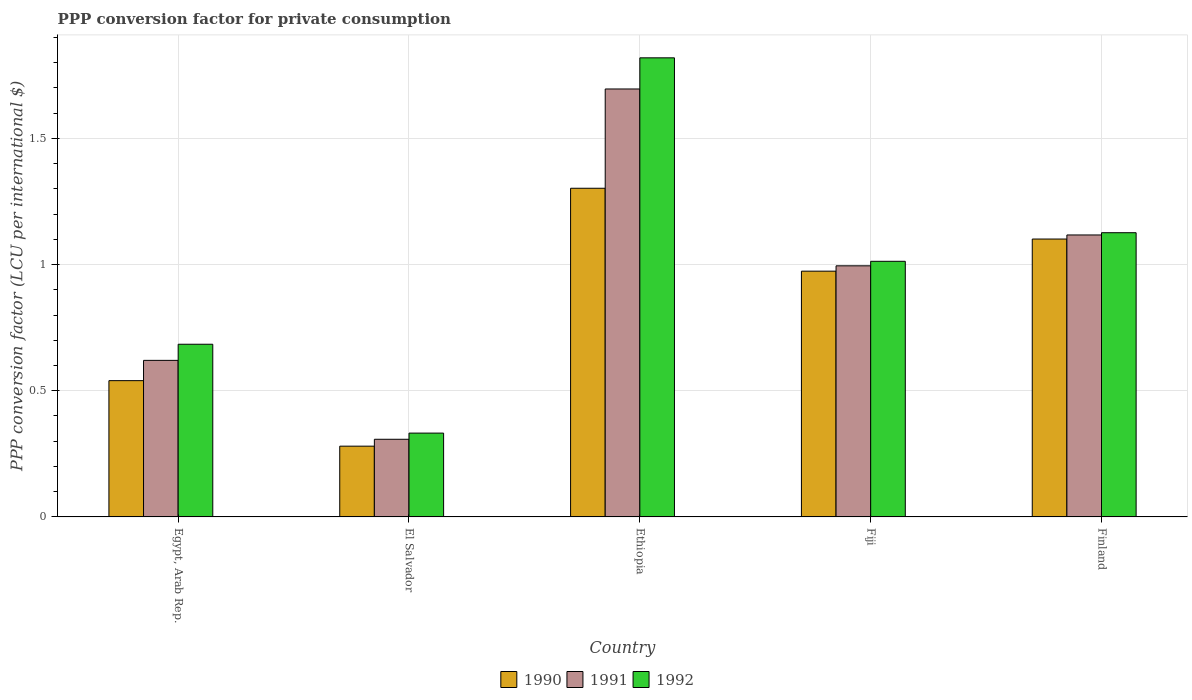How many groups of bars are there?
Keep it short and to the point. 5. How many bars are there on the 4th tick from the left?
Provide a short and direct response. 3. What is the label of the 4th group of bars from the left?
Give a very brief answer. Fiji. In how many cases, is the number of bars for a given country not equal to the number of legend labels?
Your answer should be very brief. 0. What is the PPP conversion factor for private consumption in 1992 in Egypt, Arab Rep.?
Offer a very short reply. 0.68. Across all countries, what is the maximum PPP conversion factor for private consumption in 1990?
Make the answer very short. 1.3. Across all countries, what is the minimum PPP conversion factor for private consumption in 1991?
Offer a very short reply. 0.31. In which country was the PPP conversion factor for private consumption in 1990 maximum?
Your answer should be very brief. Ethiopia. In which country was the PPP conversion factor for private consumption in 1991 minimum?
Ensure brevity in your answer.  El Salvador. What is the total PPP conversion factor for private consumption in 1990 in the graph?
Offer a terse response. 4.2. What is the difference between the PPP conversion factor for private consumption in 1991 in El Salvador and that in Finland?
Make the answer very short. -0.81. What is the difference between the PPP conversion factor for private consumption in 1992 in Fiji and the PPP conversion factor for private consumption in 1990 in Egypt, Arab Rep.?
Keep it short and to the point. 0.47. What is the average PPP conversion factor for private consumption in 1992 per country?
Ensure brevity in your answer.  0.99. What is the difference between the PPP conversion factor for private consumption of/in 1990 and PPP conversion factor for private consumption of/in 1992 in Egypt, Arab Rep.?
Your answer should be very brief. -0.14. In how many countries, is the PPP conversion factor for private consumption in 1992 greater than 1 LCU?
Offer a terse response. 3. What is the ratio of the PPP conversion factor for private consumption in 1992 in Ethiopia to that in Finland?
Provide a short and direct response. 1.62. What is the difference between the highest and the second highest PPP conversion factor for private consumption in 1992?
Provide a succinct answer. 0.69. What is the difference between the highest and the lowest PPP conversion factor for private consumption in 1991?
Offer a terse response. 1.39. In how many countries, is the PPP conversion factor for private consumption in 1990 greater than the average PPP conversion factor for private consumption in 1990 taken over all countries?
Your answer should be very brief. 3. What does the 2nd bar from the left in El Salvador represents?
Offer a very short reply. 1991. Are all the bars in the graph horizontal?
Provide a succinct answer. No. Does the graph contain grids?
Ensure brevity in your answer.  Yes. Where does the legend appear in the graph?
Your answer should be compact. Bottom center. What is the title of the graph?
Offer a terse response. PPP conversion factor for private consumption. What is the label or title of the X-axis?
Make the answer very short. Country. What is the label or title of the Y-axis?
Your response must be concise. PPP conversion factor (LCU per international $). What is the PPP conversion factor (LCU per international $) of 1990 in Egypt, Arab Rep.?
Keep it short and to the point. 0.54. What is the PPP conversion factor (LCU per international $) of 1991 in Egypt, Arab Rep.?
Your answer should be compact. 0.62. What is the PPP conversion factor (LCU per international $) of 1992 in Egypt, Arab Rep.?
Provide a succinct answer. 0.68. What is the PPP conversion factor (LCU per international $) of 1990 in El Salvador?
Offer a very short reply. 0.28. What is the PPP conversion factor (LCU per international $) of 1991 in El Salvador?
Your answer should be compact. 0.31. What is the PPP conversion factor (LCU per international $) of 1992 in El Salvador?
Keep it short and to the point. 0.33. What is the PPP conversion factor (LCU per international $) of 1990 in Ethiopia?
Ensure brevity in your answer.  1.3. What is the PPP conversion factor (LCU per international $) in 1991 in Ethiopia?
Your answer should be very brief. 1.7. What is the PPP conversion factor (LCU per international $) of 1992 in Ethiopia?
Your answer should be very brief. 1.82. What is the PPP conversion factor (LCU per international $) of 1990 in Fiji?
Your answer should be compact. 0.97. What is the PPP conversion factor (LCU per international $) of 1991 in Fiji?
Provide a short and direct response. 1. What is the PPP conversion factor (LCU per international $) of 1992 in Fiji?
Make the answer very short. 1.01. What is the PPP conversion factor (LCU per international $) in 1990 in Finland?
Make the answer very short. 1.1. What is the PPP conversion factor (LCU per international $) of 1991 in Finland?
Your answer should be compact. 1.12. What is the PPP conversion factor (LCU per international $) of 1992 in Finland?
Offer a very short reply. 1.13. Across all countries, what is the maximum PPP conversion factor (LCU per international $) of 1990?
Keep it short and to the point. 1.3. Across all countries, what is the maximum PPP conversion factor (LCU per international $) of 1991?
Give a very brief answer. 1.7. Across all countries, what is the maximum PPP conversion factor (LCU per international $) in 1992?
Offer a terse response. 1.82. Across all countries, what is the minimum PPP conversion factor (LCU per international $) in 1990?
Your answer should be very brief. 0.28. Across all countries, what is the minimum PPP conversion factor (LCU per international $) in 1991?
Your answer should be very brief. 0.31. Across all countries, what is the minimum PPP conversion factor (LCU per international $) of 1992?
Keep it short and to the point. 0.33. What is the total PPP conversion factor (LCU per international $) of 1990 in the graph?
Ensure brevity in your answer.  4.2. What is the total PPP conversion factor (LCU per international $) in 1991 in the graph?
Ensure brevity in your answer.  4.74. What is the total PPP conversion factor (LCU per international $) in 1992 in the graph?
Offer a very short reply. 4.97. What is the difference between the PPP conversion factor (LCU per international $) in 1990 in Egypt, Arab Rep. and that in El Salvador?
Your answer should be compact. 0.26. What is the difference between the PPP conversion factor (LCU per international $) in 1991 in Egypt, Arab Rep. and that in El Salvador?
Your response must be concise. 0.31. What is the difference between the PPP conversion factor (LCU per international $) of 1992 in Egypt, Arab Rep. and that in El Salvador?
Offer a very short reply. 0.35. What is the difference between the PPP conversion factor (LCU per international $) of 1990 in Egypt, Arab Rep. and that in Ethiopia?
Give a very brief answer. -0.76. What is the difference between the PPP conversion factor (LCU per international $) of 1991 in Egypt, Arab Rep. and that in Ethiopia?
Offer a very short reply. -1.08. What is the difference between the PPP conversion factor (LCU per international $) in 1992 in Egypt, Arab Rep. and that in Ethiopia?
Your answer should be very brief. -1.14. What is the difference between the PPP conversion factor (LCU per international $) of 1990 in Egypt, Arab Rep. and that in Fiji?
Your answer should be very brief. -0.43. What is the difference between the PPP conversion factor (LCU per international $) of 1991 in Egypt, Arab Rep. and that in Fiji?
Make the answer very short. -0.37. What is the difference between the PPP conversion factor (LCU per international $) of 1992 in Egypt, Arab Rep. and that in Fiji?
Provide a short and direct response. -0.33. What is the difference between the PPP conversion factor (LCU per international $) of 1990 in Egypt, Arab Rep. and that in Finland?
Provide a short and direct response. -0.56. What is the difference between the PPP conversion factor (LCU per international $) in 1991 in Egypt, Arab Rep. and that in Finland?
Your response must be concise. -0.5. What is the difference between the PPP conversion factor (LCU per international $) in 1992 in Egypt, Arab Rep. and that in Finland?
Provide a short and direct response. -0.44. What is the difference between the PPP conversion factor (LCU per international $) of 1990 in El Salvador and that in Ethiopia?
Offer a very short reply. -1.02. What is the difference between the PPP conversion factor (LCU per international $) in 1991 in El Salvador and that in Ethiopia?
Make the answer very short. -1.39. What is the difference between the PPP conversion factor (LCU per international $) of 1992 in El Salvador and that in Ethiopia?
Your answer should be compact. -1.49. What is the difference between the PPP conversion factor (LCU per international $) of 1990 in El Salvador and that in Fiji?
Your answer should be very brief. -0.69. What is the difference between the PPP conversion factor (LCU per international $) in 1991 in El Salvador and that in Fiji?
Provide a succinct answer. -0.69. What is the difference between the PPP conversion factor (LCU per international $) in 1992 in El Salvador and that in Fiji?
Provide a short and direct response. -0.68. What is the difference between the PPP conversion factor (LCU per international $) of 1990 in El Salvador and that in Finland?
Ensure brevity in your answer.  -0.82. What is the difference between the PPP conversion factor (LCU per international $) in 1991 in El Salvador and that in Finland?
Provide a succinct answer. -0.81. What is the difference between the PPP conversion factor (LCU per international $) in 1992 in El Salvador and that in Finland?
Provide a succinct answer. -0.79. What is the difference between the PPP conversion factor (LCU per international $) in 1990 in Ethiopia and that in Fiji?
Offer a very short reply. 0.33. What is the difference between the PPP conversion factor (LCU per international $) in 1991 in Ethiopia and that in Fiji?
Provide a short and direct response. 0.7. What is the difference between the PPP conversion factor (LCU per international $) in 1992 in Ethiopia and that in Fiji?
Your answer should be very brief. 0.81. What is the difference between the PPP conversion factor (LCU per international $) in 1990 in Ethiopia and that in Finland?
Provide a succinct answer. 0.2. What is the difference between the PPP conversion factor (LCU per international $) in 1991 in Ethiopia and that in Finland?
Keep it short and to the point. 0.58. What is the difference between the PPP conversion factor (LCU per international $) in 1992 in Ethiopia and that in Finland?
Give a very brief answer. 0.69. What is the difference between the PPP conversion factor (LCU per international $) in 1990 in Fiji and that in Finland?
Your response must be concise. -0.13. What is the difference between the PPP conversion factor (LCU per international $) in 1991 in Fiji and that in Finland?
Offer a very short reply. -0.12. What is the difference between the PPP conversion factor (LCU per international $) of 1992 in Fiji and that in Finland?
Your response must be concise. -0.11. What is the difference between the PPP conversion factor (LCU per international $) in 1990 in Egypt, Arab Rep. and the PPP conversion factor (LCU per international $) in 1991 in El Salvador?
Provide a succinct answer. 0.23. What is the difference between the PPP conversion factor (LCU per international $) in 1990 in Egypt, Arab Rep. and the PPP conversion factor (LCU per international $) in 1992 in El Salvador?
Give a very brief answer. 0.21. What is the difference between the PPP conversion factor (LCU per international $) of 1991 in Egypt, Arab Rep. and the PPP conversion factor (LCU per international $) of 1992 in El Salvador?
Ensure brevity in your answer.  0.29. What is the difference between the PPP conversion factor (LCU per international $) of 1990 in Egypt, Arab Rep. and the PPP conversion factor (LCU per international $) of 1991 in Ethiopia?
Keep it short and to the point. -1.16. What is the difference between the PPP conversion factor (LCU per international $) of 1990 in Egypt, Arab Rep. and the PPP conversion factor (LCU per international $) of 1992 in Ethiopia?
Keep it short and to the point. -1.28. What is the difference between the PPP conversion factor (LCU per international $) in 1991 in Egypt, Arab Rep. and the PPP conversion factor (LCU per international $) in 1992 in Ethiopia?
Offer a terse response. -1.2. What is the difference between the PPP conversion factor (LCU per international $) in 1990 in Egypt, Arab Rep. and the PPP conversion factor (LCU per international $) in 1991 in Fiji?
Provide a short and direct response. -0.46. What is the difference between the PPP conversion factor (LCU per international $) of 1990 in Egypt, Arab Rep. and the PPP conversion factor (LCU per international $) of 1992 in Fiji?
Offer a very short reply. -0.47. What is the difference between the PPP conversion factor (LCU per international $) of 1991 in Egypt, Arab Rep. and the PPP conversion factor (LCU per international $) of 1992 in Fiji?
Your answer should be compact. -0.39. What is the difference between the PPP conversion factor (LCU per international $) in 1990 in Egypt, Arab Rep. and the PPP conversion factor (LCU per international $) in 1991 in Finland?
Offer a very short reply. -0.58. What is the difference between the PPP conversion factor (LCU per international $) in 1990 in Egypt, Arab Rep. and the PPP conversion factor (LCU per international $) in 1992 in Finland?
Provide a succinct answer. -0.59. What is the difference between the PPP conversion factor (LCU per international $) in 1991 in Egypt, Arab Rep. and the PPP conversion factor (LCU per international $) in 1992 in Finland?
Give a very brief answer. -0.51. What is the difference between the PPP conversion factor (LCU per international $) in 1990 in El Salvador and the PPP conversion factor (LCU per international $) in 1991 in Ethiopia?
Your answer should be very brief. -1.42. What is the difference between the PPP conversion factor (LCU per international $) of 1990 in El Salvador and the PPP conversion factor (LCU per international $) of 1992 in Ethiopia?
Your answer should be very brief. -1.54. What is the difference between the PPP conversion factor (LCU per international $) of 1991 in El Salvador and the PPP conversion factor (LCU per international $) of 1992 in Ethiopia?
Provide a short and direct response. -1.51. What is the difference between the PPP conversion factor (LCU per international $) of 1990 in El Salvador and the PPP conversion factor (LCU per international $) of 1991 in Fiji?
Provide a succinct answer. -0.71. What is the difference between the PPP conversion factor (LCU per international $) in 1990 in El Salvador and the PPP conversion factor (LCU per international $) in 1992 in Fiji?
Provide a succinct answer. -0.73. What is the difference between the PPP conversion factor (LCU per international $) of 1991 in El Salvador and the PPP conversion factor (LCU per international $) of 1992 in Fiji?
Ensure brevity in your answer.  -0.71. What is the difference between the PPP conversion factor (LCU per international $) of 1990 in El Salvador and the PPP conversion factor (LCU per international $) of 1991 in Finland?
Offer a very short reply. -0.84. What is the difference between the PPP conversion factor (LCU per international $) of 1990 in El Salvador and the PPP conversion factor (LCU per international $) of 1992 in Finland?
Offer a very short reply. -0.85. What is the difference between the PPP conversion factor (LCU per international $) in 1991 in El Salvador and the PPP conversion factor (LCU per international $) in 1992 in Finland?
Offer a terse response. -0.82. What is the difference between the PPP conversion factor (LCU per international $) of 1990 in Ethiopia and the PPP conversion factor (LCU per international $) of 1991 in Fiji?
Provide a short and direct response. 0.31. What is the difference between the PPP conversion factor (LCU per international $) of 1990 in Ethiopia and the PPP conversion factor (LCU per international $) of 1992 in Fiji?
Make the answer very short. 0.29. What is the difference between the PPP conversion factor (LCU per international $) of 1991 in Ethiopia and the PPP conversion factor (LCU per international $) of 1992 in Fiji?
Your answer should be very brief. 0.68. What is the difference between the PPP conversion factor (LCU per international $) in 1990 in Ethiopia and the PPP conversion factor (LCU per international $) in 1991 in Finland?
Offer a very short reply. 0.19. What is the difference between the PPP conversion factor (LCU per international $) in 1990 in Ethiopia and the PPP conversion factor (LCU per international $) in 1992 in Finland?
Your answer should be compact. 0.18. What is the difference between the PPP conversion factor (LCU per international $) in 1991 in Ethiopia and the PPP conversion factor (LCU per international $) in 1992 in Finland?
Ensure brevity in your answer.  0.57. What is the difference between the PPP conversion factor (LCU per international $) in 1990 in Fiji and the PPP conversion factor (LCU per international $) in 1991 in Finland?
Offer a very short reply. -0.14. What is the difference between the PPP conversion factor (LCU per international $) in 1990 in Fiji and the PPP conversion factor (LCU per international $) in 1992 in Finland?
Make the answer very short. -0.15. What is the difference between the PPP conversion factor (LCU per international $) of 1991 in Fiji and the PPP conversion factor (LCU per international $) of 1992 in Finland?
Give a very brief answer. -0.13. What is the average PPP conversion factor (LCU per international $) of 1990 per country?
Your response must be concise. 0.84. What is the average PPP conversion factor (LCU per international $) of 1991 per country?
Offer a very short reply. 0.95. What is the difference between the PPP conversion factor (LCU per international $) in 1990 and PPP conversion factor (LCU per international $) in 1991 in Egypt, Arab Rep.?
Your answer should be very brief. -0.08. What is the difference between the PPP conversion factor (LCU per international $) of 1990 and PPP conversion factor (LCU per international $) of 1992 in Egypt, Arab Rep.?
Provide a short and direct response. -0.14. What is the difference between the PPP conversion factor (LCU per international $) in 1991 and PPP conversion factor (LCU per international $) in 1992 in Egypt, Arab Rep.?
Offer a terse response. -0.06. What is the difference between the PPP conversion factor (LCU per international $) of 1990 and PPP conversion factor (LCU per international $) of 1991 in El Salvador?
Make the answer very short. -0.03. What is the difference between the PPP conversion factor (LCU per international $) of 1990 and PPP conversion factor (LCU per international $) of 1992 in El Salvador?
Provide a succinct answer. -0.05. What is the difference between the PPP conversion factor (LCU per international $) in 1991 and PPP conversion factor (LCU per international $) in 1992 in El Salvador?
Offer a terse response. -0.02. What is the difference between the PPP conversion factor (LCU per international $) of 1990 and PPP conversion factor (LCU per international $) of 1991 in Ethiopia?
Ensure brevity in your answer.  -0.39. What is the difference between the PPP conversion factor (LCU per international $) of 1990 and PPP conversion factor (LCU per international $) of 1992 in Ethiopia?
Your answer should be very brief. -0.52. What is the difference between the PPP conversion factor (LCU per international $) in 1991 and PPP conversion factor (LCU per international $) in 1992 in Ethiopia?
Make the answer very short. -0.12. What is the difference between the PPP conversion factor (LCU per international $) in 1990 and PPP conversion factor (LCU per international $) in 1991 in Fiji?
Ensure brevity in your answer.  -0.02. What is the difference between the PPP conversion factor (LCU per international $) of 1990 and PPP conversion factor (LCU per international $) of 1992 in Fiji?
Offer a terse response. -0.04. What is the difference between the PPP conversion factor (LCU per international $) in 1991 and PPP conversion factor (LCU per international $) in 1992 in Fiji?
Offer a terse response. -0.02. What is the difference between the PPP conversion factor (LCU per international $) in 1990 and PPP conversion factor (LCU per international $) in 1991 in Finland?
Offer a very short reply. -0.02. What is the difference between the PPP conversion factor (LCU per international $) of 1990 and PPP conversion factor (LCU per international $) of 1992 in Finland?
Your answer should be compact. -0.03. What is the difference between the PPP conversion factor (LCU per international $) in 1991 and PPP conversion factor (LCU per international $) in 1992 in Finland?
Your answer should be compact. -0.01. What is the ratio of the PPP conversion factor (LCU per international $) of 1990 in Egypt, Arab Rep. to that in El Salvador?
Offer a terse response. 1.93. What is the ratio of the PPP conversion factor (LCU per international $) in 1991 in Egypt, Arab Rep. to that in El Salvador?
Keep it short and to the point. 2.02. What is the ratio of the PPP conversion factor (LCU per international $) of 1992 in Egypt, Arab Rep. to that in El Salvador?
Your response must be concise. 2.06. What is the ratio of the PPP conversion factor (LCU per international $) in 1990 in Egypt, Arab Rep. to that in Ethiopia?
Provide a succinct answer. 0.41. What is the ratio of the PPP conversion factor (LCU per international $) of 1991 in Egypt, Arab Rep. to that in Ethiopia?
Offer a very short reply. 0.37. What is the ratio of the PPP conversion factor (LCU per international $) in 1992 in Egypt, Arab Rep. to that in Ethiopia?
Offer a terse response. 0.38. What is the ratio of the PPP conversion factor (LCU per international $) in 1990 in Egypt, Arab Rep. to that in Fiji?
Provide a short and direct response. 0.55. What is the ratio of the PPP conversion factor (LCU per international $) of 1991 in Egypt, Arab Rep. to that in Fiji?
Your answer should be very brief. 0.62. What is the ratio of the PPP conversion factor (LCU per international $) of 1992 in Egypt, Arab Rep. to that in Fiji?
Offer a very short reply. 0.68. What is the ratio of the PPP conversion factor (LCU per international $) of 1990 in Egypt, Arab Rep. to that in Finland?
Your response must be concise. 0.49. What is the ratio of the PPP conversion factor (LCU per international $) in 1991 in Egypt, Arab Rep. to that in Finland?
Give a very brief answer. 0.56. What is the ratio of the PPP conversion factor (LCU per international $) of 1992 in Egypt, Arab Rep. to that in Finland?
Give a very brief answer. 0.61. What is the ratio of the PPP conversion factor (LCU per international $) in 1990 in El Salvador to that in Ethiopia?
Keep it short and to the point. 0.22. What is the ratio of the PPP conversion factor (LCU per international $) in 1991 in El Salvador to that in Ethiopia?
Your response must be concise. 0.18. What is the ratio of the PPP conversion factor (LCU per international $) in 1992 in El Salvador to that in Ethiopia?
Offer a terse response. 0.18. What is the ratio of the PPP conversion factor (LCU per international $) in 1990 in El Salvador to that in Fiji?
Make the answer very short. 0.29. What is the ratio of the PPP conversion factor (LCU per international $) in 1991 in El Salvador to that in Fiji?
Offer a terse response. 0.31. What is the ratio of the PPP conversion factor (LCU per international $) of 1992 in El Salvador to that in Fiji?
Provide a short and direct response. 0.33. What is the ratio of the PPP conversion factor (LCU per international $) in 1990 in El Salvador to that in Finland?
Your response must be concise. 0.25. What is the ratio of the PPP conversion factor (LCU per international $) in 1991 in El Salvador to that in Finland?
Provide a short and direct response. 0.28. What is the ratio of the PPP conversion factor (LCU per international $) of 1992 in El Salvador to that in Finland?
Offer a very short reply. 0.29. What is the ratio of the PPP conversion factor (LCU per international $) in 1990 in Ethiopia to that in Fiji?
Your answer should be very brief. 1.34. What is the ratio of the PPP conversion factor (LCU per international $) in 1991 in Ethiopia to that in Fiji?
Offer a very short reply. 1.7. What is the ratio of the PPP conversion factor (LCU per international $) of 1992 in Ethiopia to that in Fiji?
Provide a short and direct response. 1.8. What is the ratio of the PPP conversion factor (LCU per international $) of 1990 in Ethiopia to that in Finland?
Offer a terse response. 1.18. What is the ratio of the PPP conversion factor (LCU per international $) of 1991 in Ethiopia to that in Finland?
Your answer should be very brief. 1.52. What is the ratio of the PPP conversion factor (LCU per international $) of 1992 in Ethiopia to that in Finland?
Keep it short and to the point. 1.62. What is the ratio of the PPP conversion factor (LCU per international $) of 1990 in Fiji to that in Finland?
Ensure brevity in your answer.  0.88. What is the ratio of the PPP conversion factor (LCU per international $) of 1991 in Fiji to that in Finland?
Keep it short and to the point. 0.89. What is the ratio of the PPP conversion factor (LCU per international $) in 1992 in Fiji to that in Finland?
Offer a terse response. 0.9. What is the difference between the highest and the second highest PPP conversion factor (LCU per international $) in 1990?
Keep it short and to the point. 0.2. What is the difference between the highest and the second highest PPP conversion factor (LCU per international $) in 1991?
Keep it short and to the point. 0.58. What is the difference between the highest and the second highest PPP conversion factor (LCU per international $) of 1992?
Ensure brevity in your answer.  0.69. What is the difference between the highest and the lowest PPP conversion factor (LCU per international $) in 1990?
Offer a terse response. 1.02. What is the difference between the highest and the lowest PPP conversion factor (LCU per international $) of 1991?
Provide a short and direct response. 1.39. What is the difference between the highest and the lowest PPP conversion factor (LCU per international $) of 1992?
Ensure brevity in your answer.  1.49. 